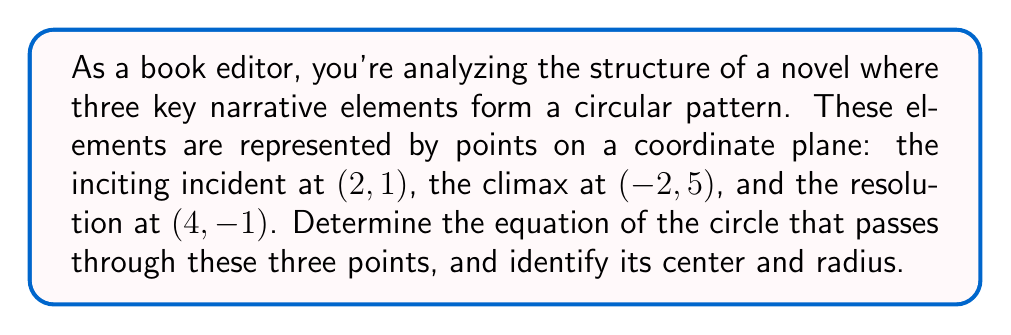Provide a solution to this math problem. Let's approach this step-by-step:

1) The general equation of a circle is $$(x-h)^2 + (y-k)^2 = r^2$$
   where $(h,k)$ is the center and $r$ is the radius.

2) We need to find $h$, $k$, and $r$ using the given three points.

3) To find the center, we can use the perpendicular bisector method:
   
   a) Find the midpoint of two chords and their perpendicular slopes.
   b) The intersection of these perpendicular bisectors is the center.

4) Midpoint of points (2,1) and (-2,5):
   $(\frac{2+(-2)}{2}, \frac{1+5}{2}) = (0,3)$

5) Midpoint of points (2,1) and (4,-1):
   $(\frac{2+4}{2}, \frac{1+(-1)}{2}) = (3,0)$

6) Slope of line through (2,1) and (-2,5): $m_1 = \frac{5-1}{-2-2} = -1$
   Perpendicular slope: $m_1^\perp = 1$

7) Slope of line through (2,1) and (4,-1): $m_2 = \frac{-1-1}{4-2} = -1$
   Perpendicular slope: $m_2^\perp = 1$

8) Equations of perpendicular bisectors:
   $y - 3 = 1(x - 0)$ and $y - 0 = 1(x - 3)$

9) Solving these simultaneously:
   $y = x + 3$ and $y = x - 3$
   $x + 3 = x - 3$
   $6 = 0$
   $x = 3$, $y = 0$

10) The center is at (3,0).

11) To find the radius, we can use the distance formula from the center to any of the given points:

    $r = \sqrt{(2-3)^2 + (1-0)^2} = \sqrt{(-1)^2 + 1^2} = \sqrt{2}$

12) Therefore, the equation of the circle is:
    $$(x-3)^2 + (y-0)^2 = 2$$

[asy]
import geometry;

pair A = (2,1);
pair B = (-2,5);
pair C = (4,-1);
pair O = (3,0);

draw(circle(O, sqrt(2)));
dot("A", A, SE);
dot("B", B, NW);
dot("C", C, SE);
dot("O", O, E);

draw(A--B--C--cycle, dashed);
draw(O--A, Arrow);

label("r", (O--A)/2, N);

xaxis(-3,5,Arrow);
yaxis(-2,6,Arrow);
</asy>
Answer: The equation of the circle is $(x-3)^2 + y^2 = 2$. The center is at (3,0) and the radius is $\sqrt{2}$. 